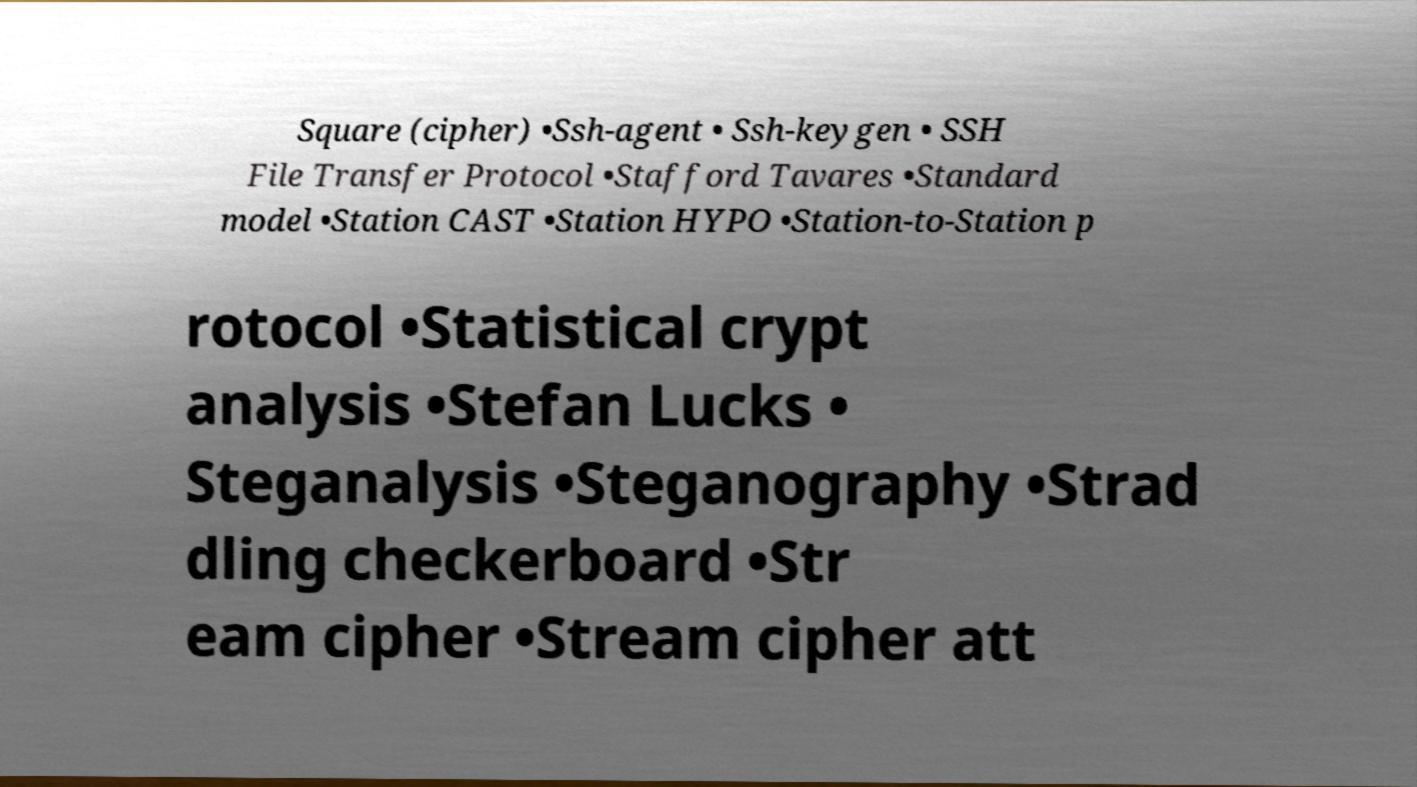Could you extract and type out the text from this image? Square (cipher) •Ssh-agent • Ssh-keygen • SSH File Transfer Protocol •Stafford Tavares •Standard model •Station CAST •Station HYPO •Station-to-Station p rotocol •Statistical crypt analysis •Stefan Lucks • Steganalysis •Steganography •Strad dling checkerboard •Str eam cipher •Stream cipher att 